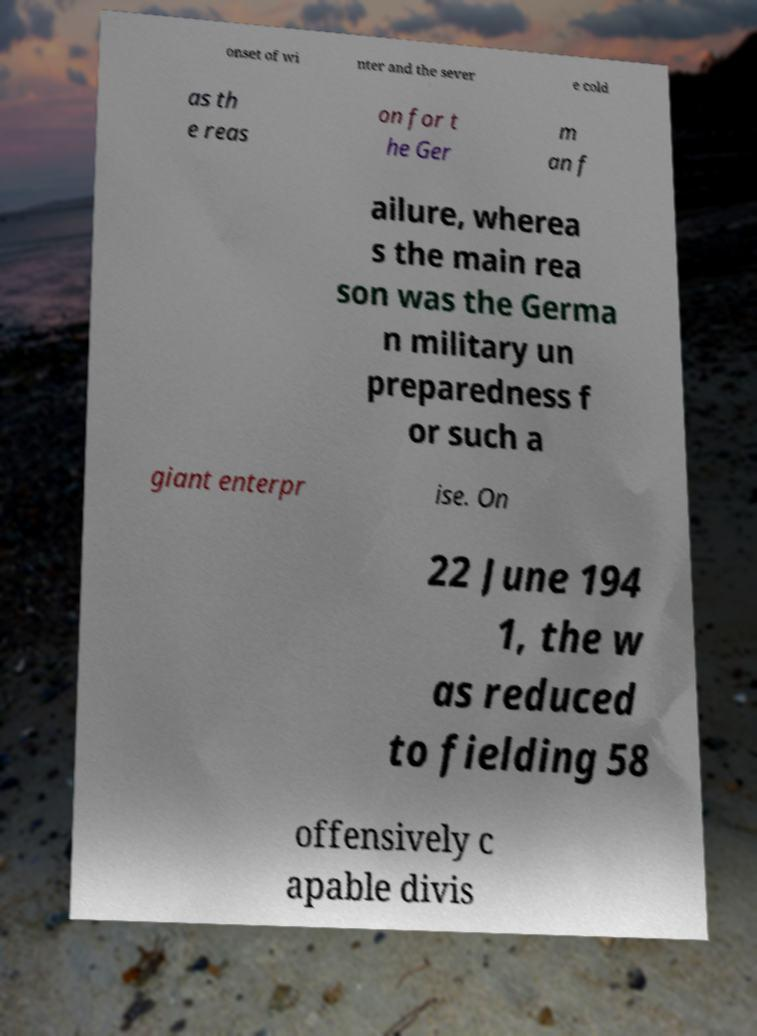Can you accurately transcribe the text from the provided image for me? onset of wi nter and the sever e cold as th e reas on for t he Ger m an f ailure, wherea s the main rea son was the Germa n military un preparedness f or such a giant enterpr ise. On 22 June 194 1, the w as reduced to fielding 58 offensively c apable divis 